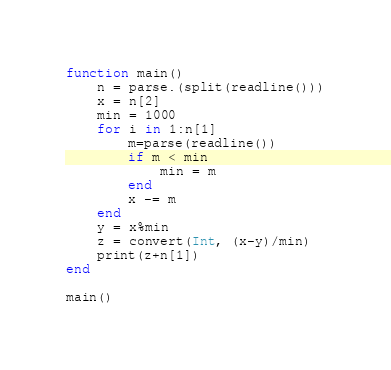<code> <loc_0><loc_0><loc_500><loc_500><_Julia_>function main()
	n = parse.(split(readline()))
	x = n[2]
	min = 1000
	for i in 1:n[1]
		m=parse(readline())
		if m < min
			min = m
		end
		x -= m
	end
	y = x%min
	z = convert(Int, (x-y)/min)
	print(z+n[1])
end

main()</code> 